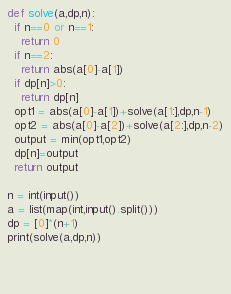<code> <loc_0><loc_0><loc_500><loc_500><_Python_>def solve(a,dp,n):
  if n==0 or n==1:
    return 0
  if n==2:
    return abs(a[0]-a[1])
  if dp[n]>0:
    return dp[n]
  opt1 = abs(a[0]-a[1])+solve(a[1:],dp,n-1)
  opt2 = abs(a[0]-a[2])+solve(a[2:],dp,n-2)
  output = min(opt1,opt2)
  dp[n]=output
  return output

n = int(input())
a = list(map(int,input().split()))
dp = [0]*(n+1)
print(solve(a,dp,n))


 </code> 